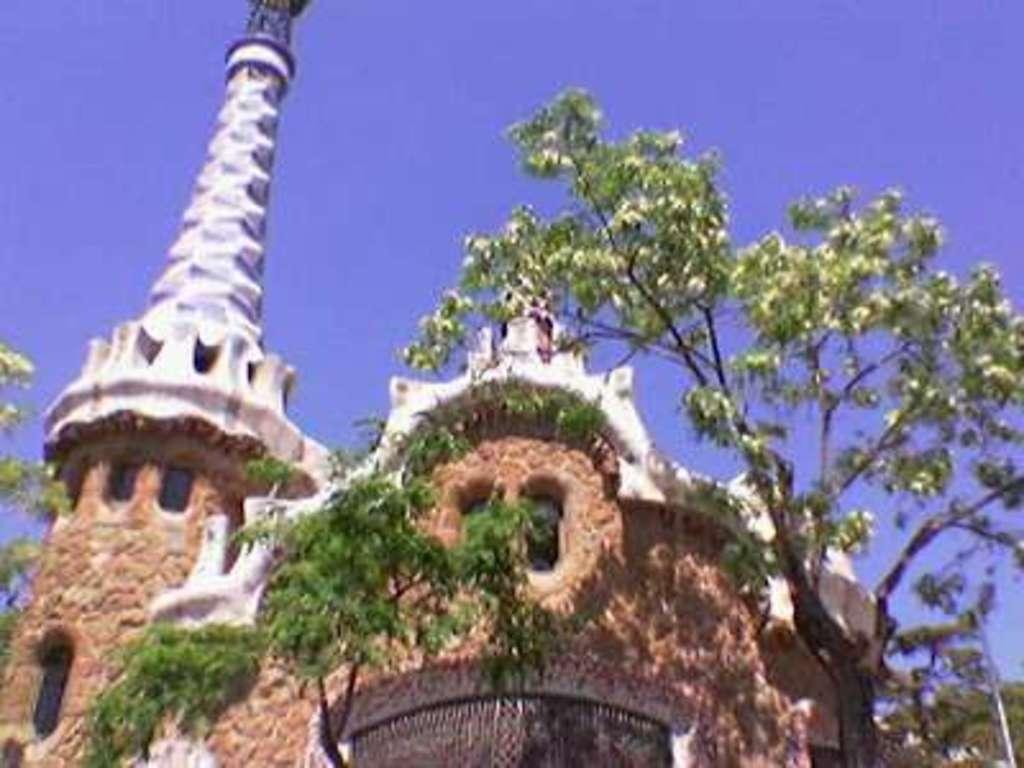What type of structure is present in the image? There is a building in the image. What is the entrance to the building like? There is a gate in the image. What type of vegetation can be seen in the image? There are trees in the image. What can be seen in the distance in the image? The sky is visible in the background of the image. What word is written on the tub in the image? There is no tub present in the image, so it is not possible to answer that question. 